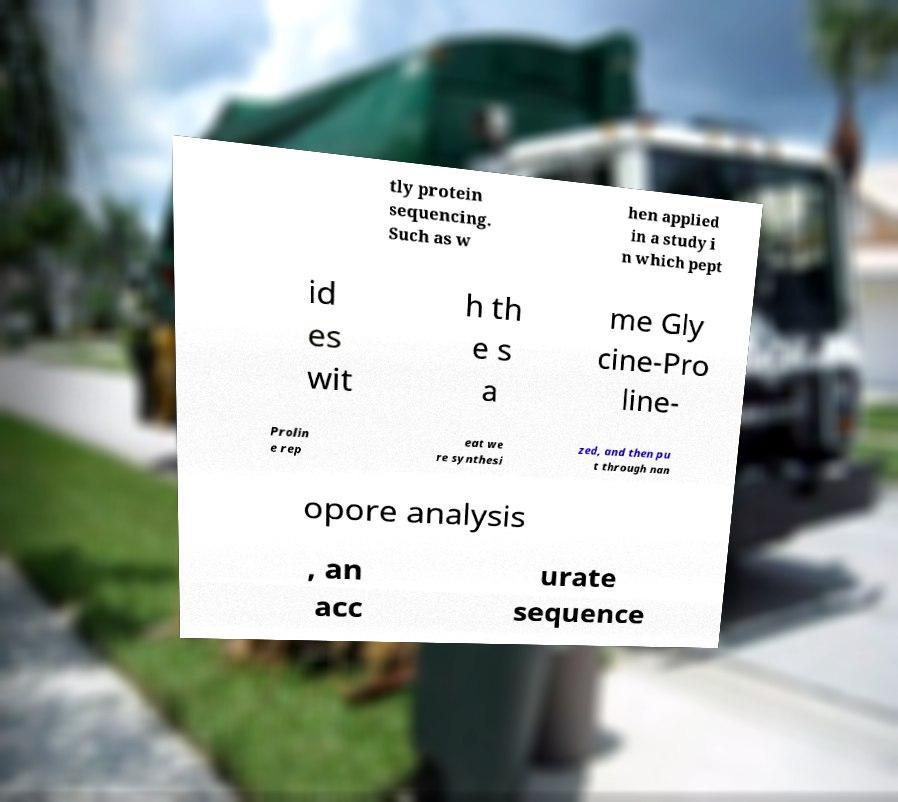Can you read and provide the text displayed in the image?This photo seems to have some interesting text. Can you extract and type it out for me? tly protein sequencing. Such as w hen applied in a study i n which pept id es wit h th e s a me Gly cine-Pro line- Prolin e rep eat we re synthesi zed, and then pu t through nan opore analysis , an acc urate sequence 